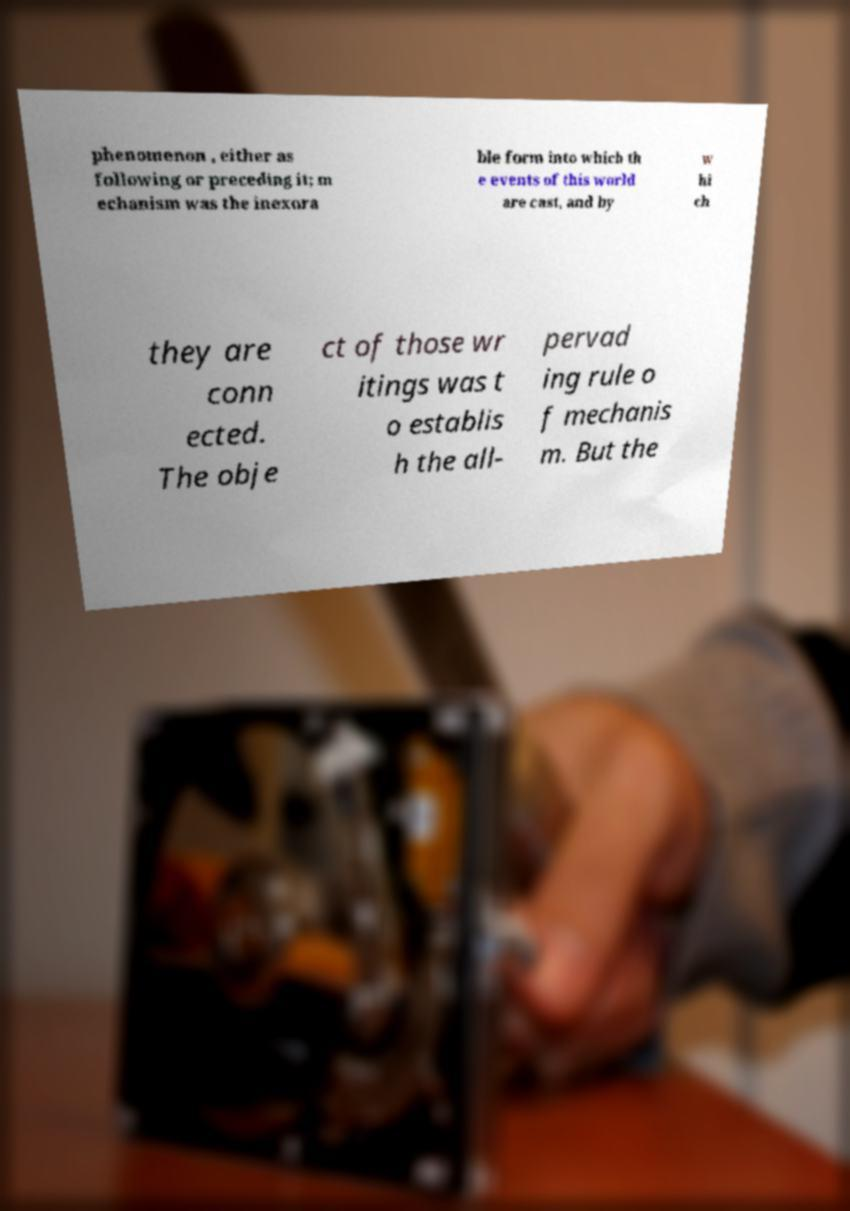Can you read and provide the text displayed in the image?This photo seems to have some interesting text. Can you extract and type it out for me? phenomenon , either as following or preceding it; m echanism was the inexora ble form into which th e events of this world are cast, and by w hi ch they are conn ected. The obje ct of those wr itings was t o establis h the all- pervad ing rule o f mechanis m. But the 